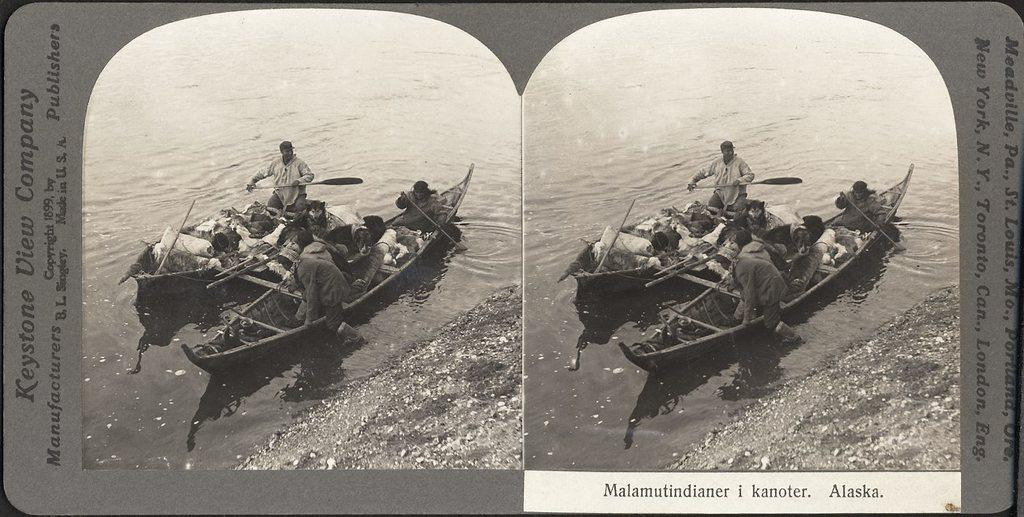What type of artwork is shown in the image? The image is a collage. What can be seen on the boats in the image? There are people and objects on the boats. Where are the boats located in the image? The boats are on the water. Are there any text elements in the image? Yes, there are letters on the image. Can you see a knot being tied on one of the boats in the image? There is no knot-tying activity depicted in the image. Is there a hydrant visible on any of the boats in the image? There is no hydrant present on any of the boats in the image. 